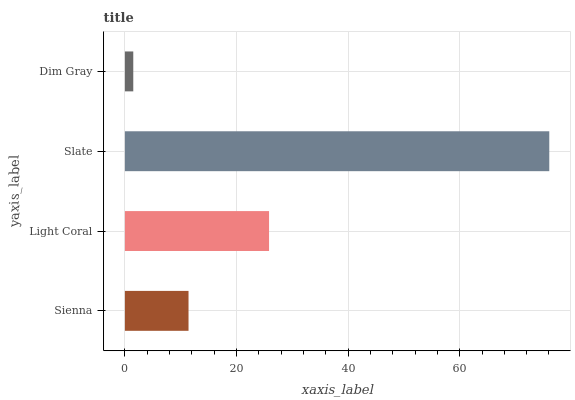Is Dim Gray the minimum?
Answer yes or no. Yes. Is Slate the maximum?
Answer yes or no. Yes. Is Light Coral the minimum?
Answer yes or no. No. Is Light Coral the maximum?
Answer yes or no. No. Is Light Coral greater than Sienna?
Answer yes or no. Yes. Is Sienna less than Light Coral?
Answer yes or no. Yes. Is Sienna greater than Light Coral?
Answer yes or no. No. Is Light Coral less than Sienna?
Answer yes or no. No. Is Light Coral the high median?
Answer yes or no. Yes. Is Sienna the low median?
Answer yes or no. Yes. Is Dim Gray the high median?
Answer yes or no. No. Is Slate the low median?
Answer yes or no. No. 